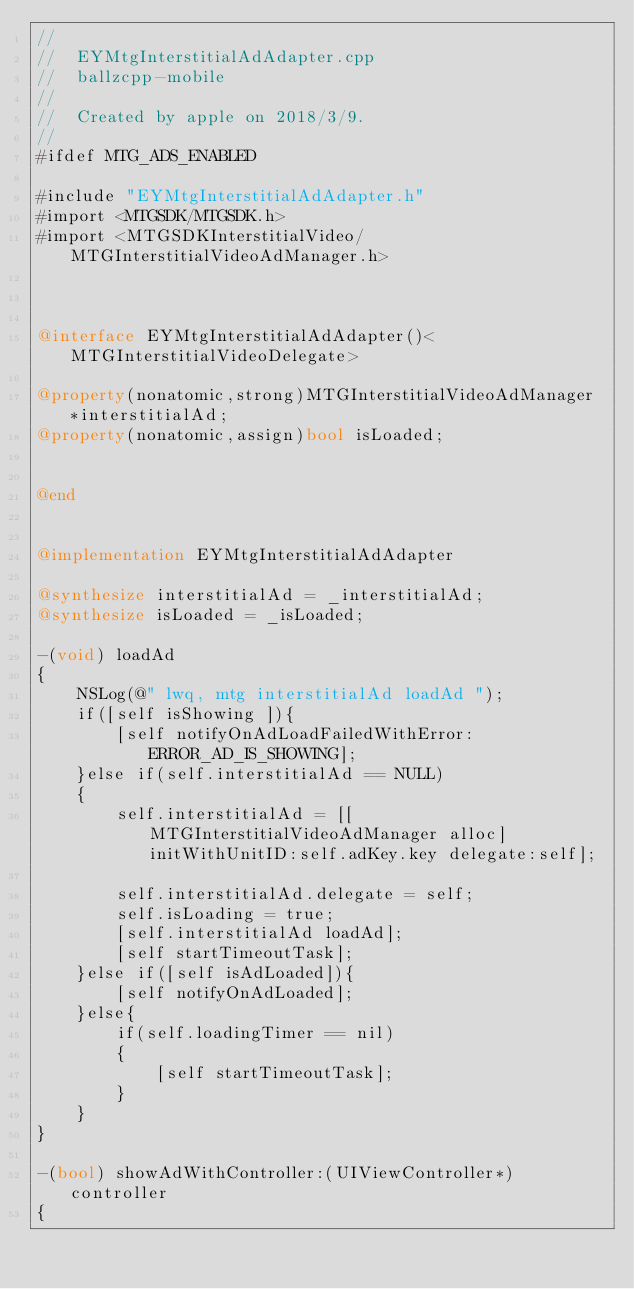Convert code to text. <code><loc_0><loc_0><loc_500><loc_500><_ObjectiveC_>//
//  EYMtgInterstitialAdAdapter.cpp
//  ballzcpp-mobile
//
//  Created by apple on 2018/3/9.
//
#ifdef MTG_ADS_ENABLED

#include "EYMtgInterstitialAdAdapter.h"
#import <MTGSDK/MTGSDK.h>
#import <MTGSDKInterstitialVideo/MTGInterstitialVideoAdManager.h>



@interface EYMtgInterstitialAdAdapter()<MTGInterstitialVideoDelegate>

@property(nonatomic,strong)MTGInterstitialVideoAdManager *interstitialAd;
@property(nonatomic,assign)bool isLoaded;


@end


@implementation EYMtgInterstitialAdAdapter

@synthesize interstitialAd = _interstitialAd;
@synthesize isLoaded = _isLoaded;

-(void) loadAd
{
    NSLog(@" lwq, mtg interstitialAd loadAd ");
    if([self isShowing ]){
        [self notifyOnAdLoadFailedWithError:ERROR_AD_IS_SHOWING];
    }else if(self.interstitialAd == NULL)
    {
        self.interstitialAd = [[MTGInterstitialVideoAdManager alloc] initWithUnitID:self.adKey.key delegate:self];

        self.interstitialAd.delegate = self;
        self.isLoading = true;
        [self.interstitialAd loadAd];
        [self startTimeoutTask];
    }else if([self isAdLoaded]){
        [self notifyOnAdLoaded];
    }else{
        if(self.loadingTimer == nil)
        {
            [self startTimeoutTask];
        }
    }
}

-(bool) showAdWithController:(UIViewController*) controller
{</code> 